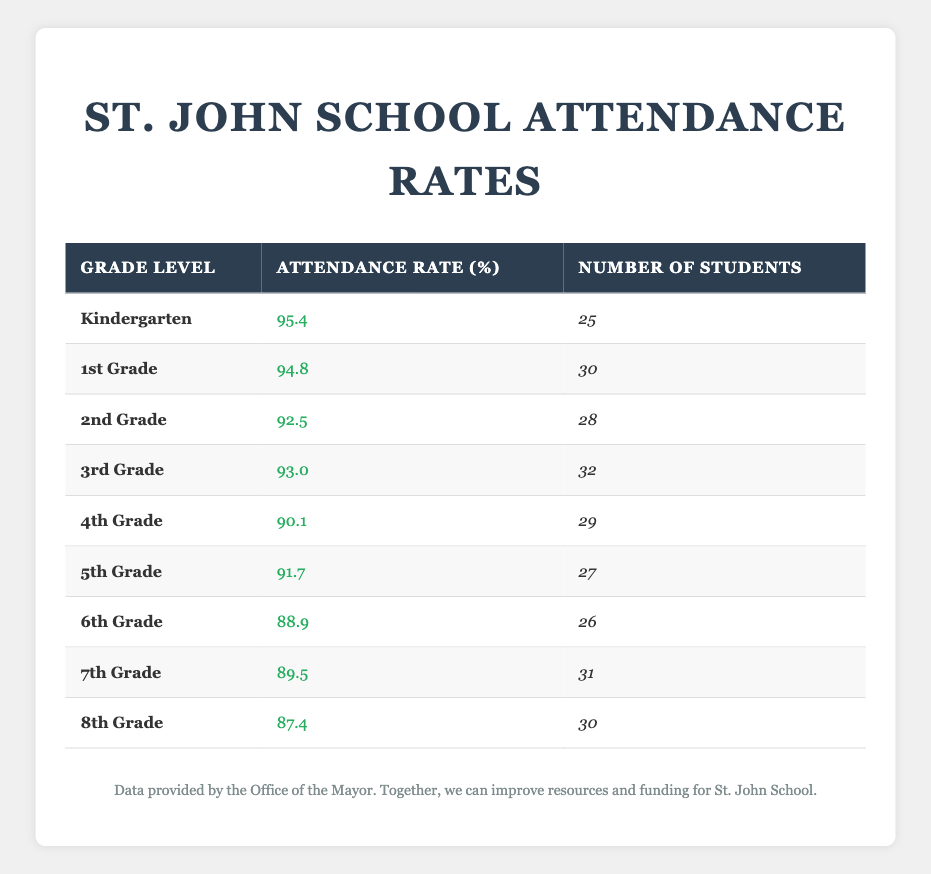What is the attendance rate for 4th Grade? The table lists the attendance rate for each grade, and for 4th Grade, the specified attendance rate is 90.1%.
Answer: 90.1% How many students are there in 2nd Grade? According to the table, the number of students in 2nd Grade is 28.
Answer: 28 Which grade has the highest attendance rate? After reviewing the attendance rates in the table, Kindergarten has the highest attendance rate at 95.4%.
Answer: Kindergarten What is the average attendance rate for grades 6th to 8th? To calculate the average attendance rate for grades 6th, 7th, and 8th, we add their rates (88.9 + 89.5 + 87.4 = 265.8) and divide by 3, resulting in an average of approximately 88.6%.
Answer: 88.6% Is the attendance rate for 5th Grade higher than 90%? The attendance rate for 5th Grade is 91.7%, which is greater than 90%. Therefore, the statement is true.
Answer: Yes How many total students are there from Kindergarten to 3rd Grade? The total number of students in Kindergarten (25), 1st Grade (30), 2nd Grade (28), and 3rd Grade (32) is calculated: 25 + 30 + 28 + 32 = 115.
Answer: 115 Which grade has the lowest attendance rate? Upon examining the table, the grade with the lowest attendance rate is 8th Grade at 87.4%.
Answer: 8th Grade What is the difference in attendance rates between 1st Grade and 3rd Grade? The attendance rate for 1st Grade is 94.8%, and for 3rd Grade, it is 93.0%. Subtracting these two rates gives 94.8 - 93.0 = 1.8%, indicating that 1st Grade has a higher rate by this amount.
Answer: 1.8% What percentage of students in 7th Grade attended school? The attendance rate for 7th Grade is 89.5%, which reflects the percentage of students who attended school.
Answer: 89.5% How does the attendance rate for 4th Grade compare to the average attendance rate of all grades? The attendance rate for 4th Grade is 90.1%. The average can be calculated by adding all attendance rates (95.4 + 94.8 + 92.5 + 93.0 + 90.1 + 91.7 + 88.9 + 89.5 + 87.4 =  91.0) and dividing by 9. Since 90.1 is less than 91.0, 4th Grade is below average.
Answer: Below average 